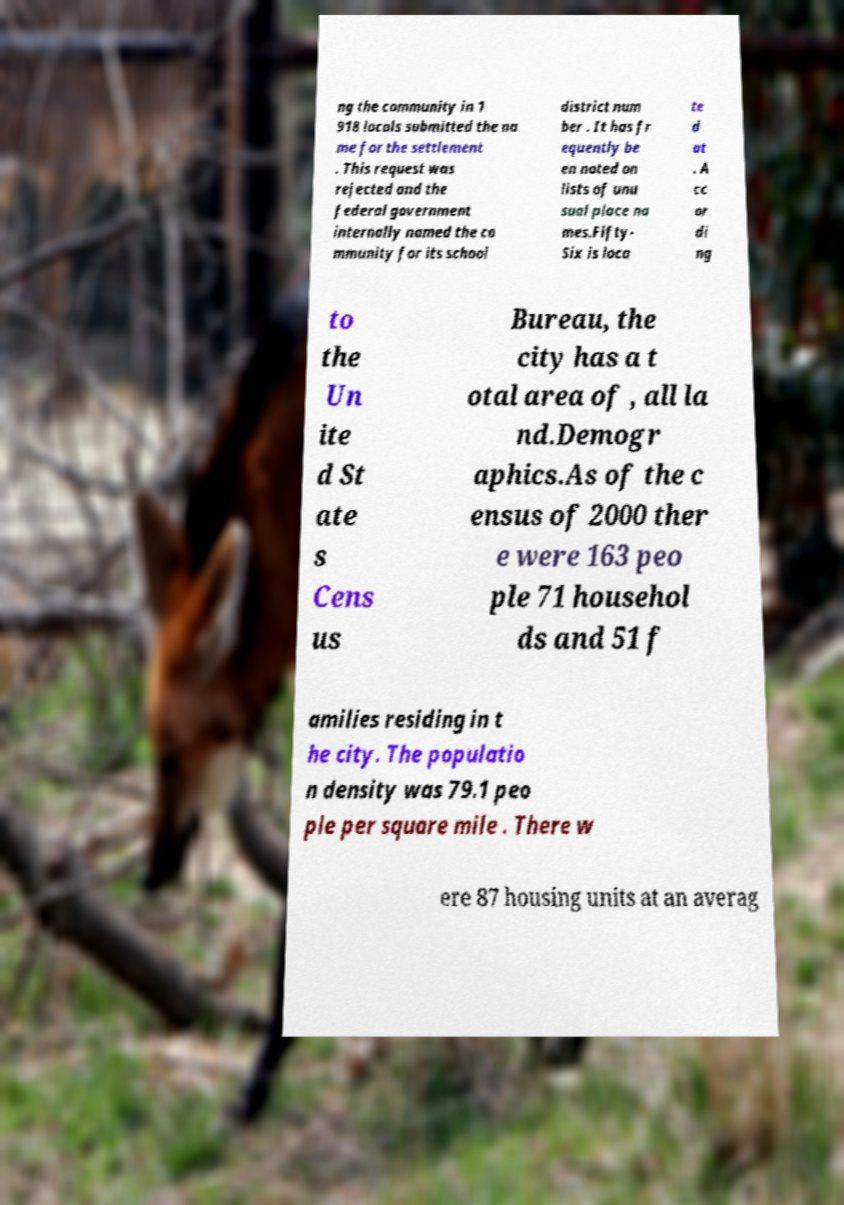What messages or text are displayed in this image? I need them in a readable, typed format. ng the community in 1 918 locals submitted the na me for the settlement . This request was rejected and the federal government internally named the co mmunity for its school district num ber . It has fr equently be en noted on lists of unu sual place na mes.Fifty- Six is loca te d at . A cc or di ng to the Un ite d St ate s Cens us Bureau, the city has a t otal area of , all la nd.Demogr aphics.As of the c ensus of 2000 ther e were 163 peo ple 71 househol ds and 51 f amilies residing in t he city. The populatio n density was 79.1 peo ple per square mile . There w ere 87 housing units at an averag 